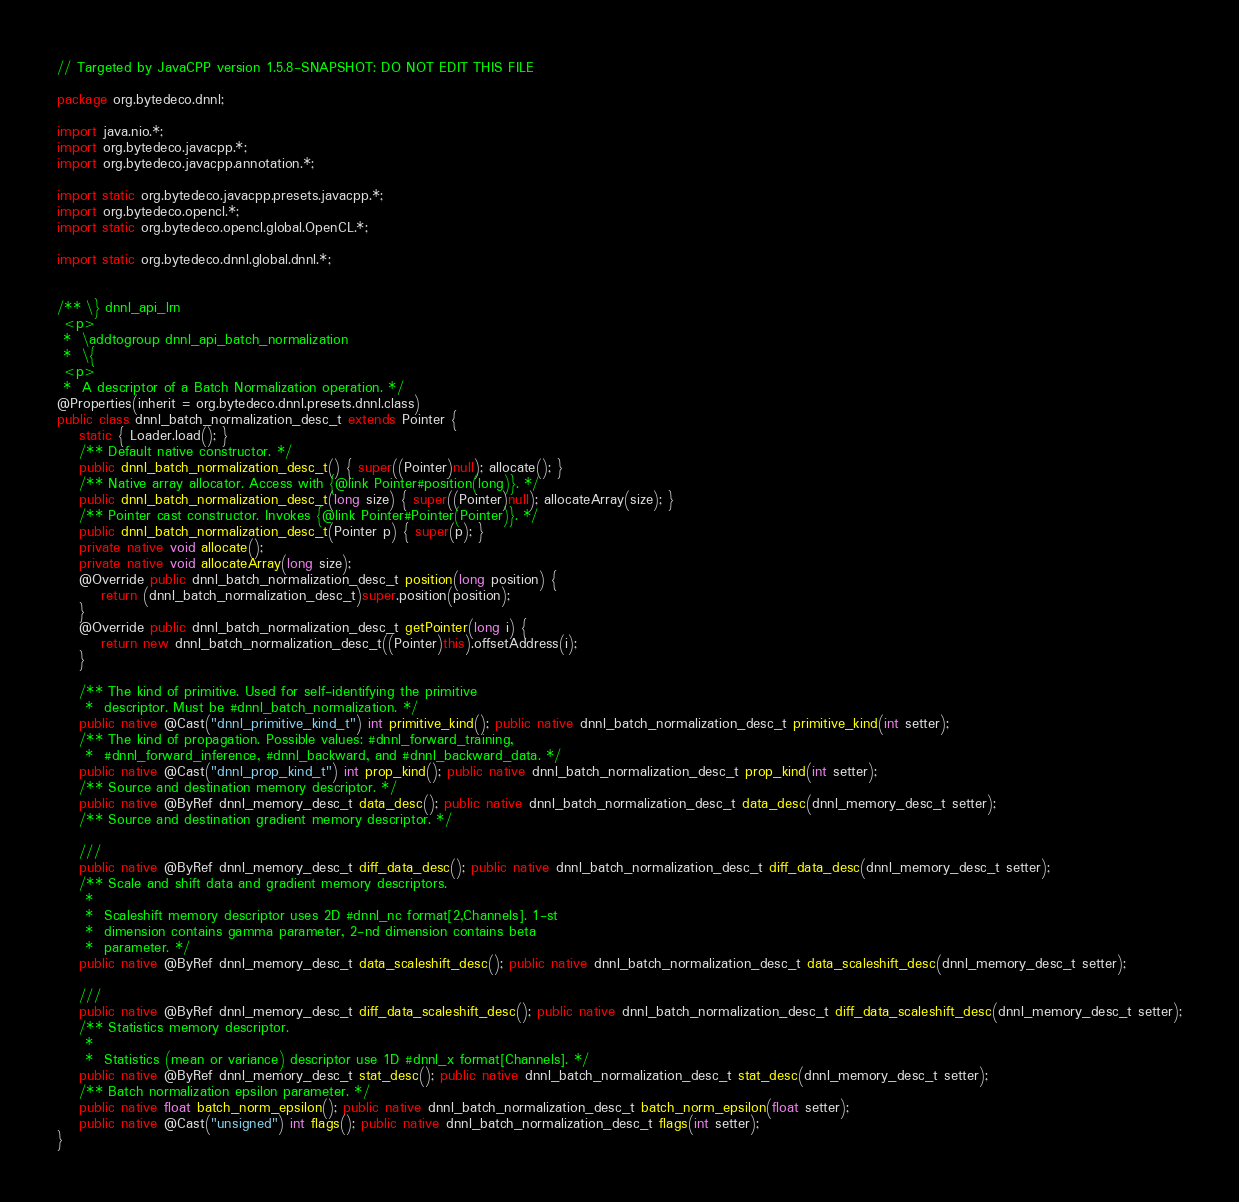Convert code to text. <code><loc_0><loc_0><loc_500><loc_500><_Java_>// Targeted by JavaCPP version 1.5.8-SNAPSHOT: DO NOT EDIT THIS FILE

package org.bytedeco.dnnl;

import java.nio.*;
import org.bytedeco.javacpp.*;
import org.bytedeco.javacpp.annotation.*;

import static org.bytedeco.javacpp.presets.javacpp.*;
import org.bytedeco.opencl.*;
import static org.bytedeco.opencl.global.OpenCL.*;

import static org.bytedeco.dnnl.global.dnnl.*;


/** \} dnnl_api_lrn
 <p>
 *  \addtogroup dnnl_api_batch_normalization
 *  \{
 <p>
 *  A descriptor of a Batch Normalization operation. */
@Properties(inherit = org.bytedeco.dnnl.presets.dnnl.class)
public class dnnl_batch_normalization_desc_t extends Pointer {
    static { Loader.load(); }
    /** Default native constructor. */
    public dnnl_batch_normalization_desc_t() { super((Pointer)null); allocate(); }
    /** Native array allocator. Access with {@link Pointer#position(long)}. */
    public dnnl_batch_normalization_desc_t(long size) { super((Pointer)null); allocateArray(size); }
    /** Pointer cast constructor. Invokes {@link Pointer#Pointer(Pointer)}. */
    public dnnl_batch_normalization_desc_t(Pointer p) { super(p); }
    private native void allocate();
    private native void allocateArray(long size);
    @Override public dnnl_batch_normalization_desc_t position(long position) {
        return (dnnl_batch_normalization_desc_t)super.position(position);
    }
    @Override public dnnl_batch_normalization_desc_t getPointer(long i) {
        return new dnnl_batch_normalization_desc_t((Pointer)this).offsetAddress(i);
    }

    /** The kind of primitive. Used for self-identifying the primitive
     *  descriptor. Must be #dnnl_batch_normalization. */
    public native @Cast("dnnl_primitive_kind_t") int primitive_kind(); public native dnnl_batch_normalization_desc_t primitive_kind(int setter);
    /** The kind of propagation. Possible values: #dnnl_forward_training,
     *  #dnnl_forward_inference, #dnnl_backward, and #dnnl_backward_data. */
    public native @Cast("dnnl_prop_kind_t") int prop_kind(); public native dnnl_batch_normalization_desc_t prop_kind(int setter);
    /** Source and destination memory descriptor. */
    public native @ByRef dnnl_memory_desc_t data_desc(); public native dnnl_batch_normalization_desc_t data_desc(dnnl_memory_desc_t setter);
    /** Source and destination gradient memory descriptor. */
    
    ///
    public native @ByRef dnnl_memory_desc_t diff_data_desc(); public native dnnl_batch_normalization_desc_t diff_data_desc(dnnl_memory_desc_t setter);
    /** Scale and shift data and gradient memory descriptors.
     * 
     *  Scaleshift memory descriptor uses 2D #dnnl_nc format[2,Channels]. 1-st
     *  dimension contains gamma parameter, 2-nd dimension contains beta
     *  parameter. */
    public native @ByRef dnnl_memory_desc_t data_scaleshift_desc(); public native dnnl_batch_normalization_desc_t data_scaleshift_desc(dnnl_memory_desc_t setter);
    
    ///
    public native @ByRef dnnl_memory_desc_t diff_data_scaleshift_desc(); public native dnnl_batch_normalization_desc_t diff_data_scaleshift_desc(dnnl_memory_desc_t setter);
    /** Statistics memory descriptor.
     * 
     *  Statistics (mean or variance) descriptor use 1D #dnnl_x format[Channels]. */
    public native @ByRef dnnl_memory_desc_t stat_desc(); public native dnnl_batch_normalization_desc_t stat_desc(dnnl_memory_desc_t setter);
    /** Batch normalization epsilon parameter. */
    public native float batch_norm_epsilon(); public native dnnl_batch_normalization_desc_t batch_norm_epsilon(float setter);
    public native @Cast("unsigned") int flags(); public native dnnl_batch_normalization_desc_t flags(int setter);
}
</code> 